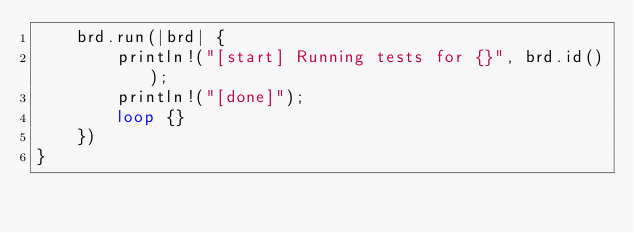Convert code to text. <code><loc_0><loc_0><loc_500><loc_500><_Rust_>    brd.run(|brd| {
        println!("[start] Running tests for {}", brd.id());
        println!("[done]");
        loop {}
    })
}</code> 